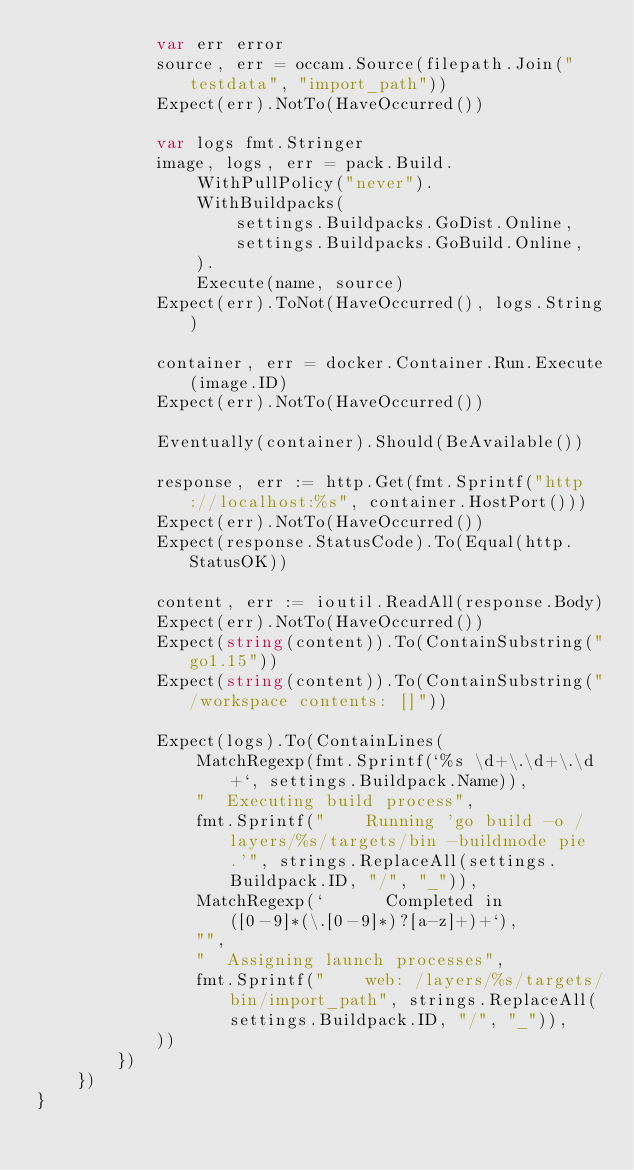Convert code to text. <code><loc_0><loc_0><loc_500><loc_500><_Go_>			var err error
			source, err = occam.Source(filepath.Join("testdata", "import_path"))
			Expect(err).NotTo(HaveOccurred())

			var logs fmt.Stringer
			image, logs, err = pack.Build.
				WithPullPolicy("never").
				WithBuildpacks(
					settings.Buildpacks.GoDist.Online,
					settings.Buildpacks.GoBuild.Online,
				).
				Execute(name, source)
			Expect(err).ToNot(HaveOccurred(), logs.String)

			container, err = docker.Container.Run.Execute(image.ID)
			Expect(err).NotTo(HaveOccurred())

			Eventually(container).Should(BeAvailable())

			response, err := http.Get(fmt.Sprintf("http://localhost:%s", container.HostPort()))
			Expect(err).NotTo(HaveOccurred())
			Expect(response.StatusCode).To(Equal(http.StatusOK))

			content, err := ioutil.ReadAll(response.Body)
			Expect(err).NotTo(HaveOccurred())
			Expect(string(content)).To(ContainSubstring("go1.15"))
			Expect(string(content)).To(ContainSubstring("/workspace contents: []"))

			Expect(logs).To(ContainLines(
				MatchRegexp(fmt.Sprintf(`%s \d+\.\d+\.\d+`, settings.Buildpack.Name)),
				"  Executing build process",
				fmt.Sprintf("    Running 'go build -o /layers/%s/targets/bin -buildmode pie .'", strings.ReplaceAll(settings.Buildpack.ID, "/", "_")),
				MatchRegexp(`      Completed in ([0-9]*(\.[0-9]*)?[a-z]+)+`),
				"",
				"  Assigning launch processes",
				fmt.Sprintf("    web: /layers/%s/targets/bin/import_path", strings.ReplaceAll(settings.Buildpack.ID, "/", "_")),
			))
		})
	})
}
</code> 